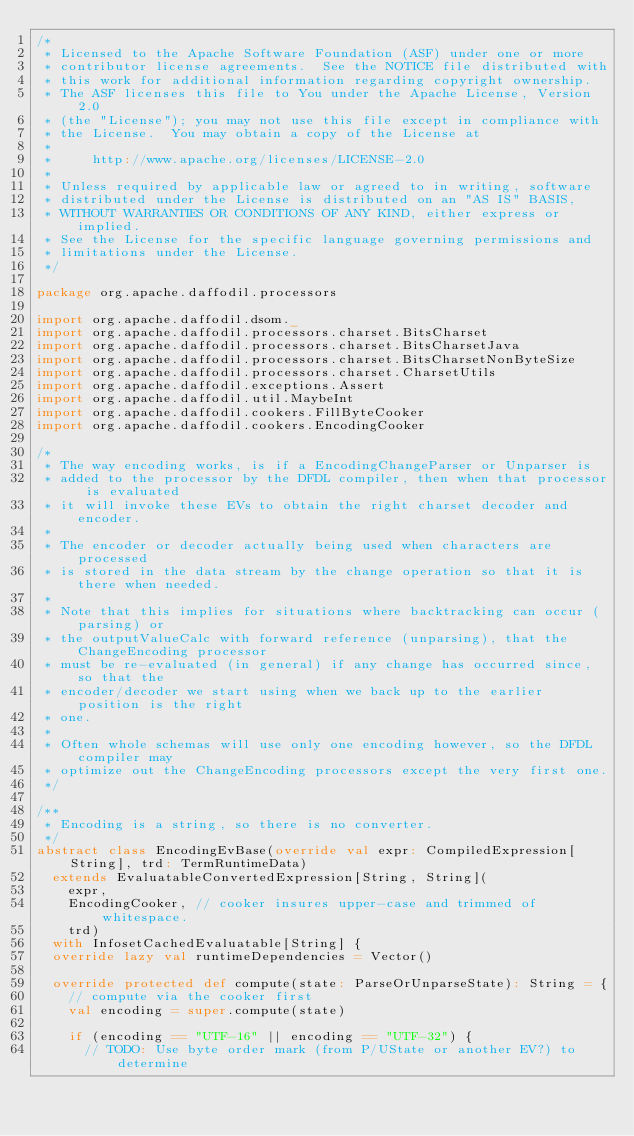Convert code to text. <code><loc_0><loc_0><loc_500><loc_500><_Scala_>/*
 * Licensed to the Apache Software Foundation (ASF) under one or more
 * contributor license agreements.  See the NOTICE file distributed with
 * this work for additional information regarding copyright ownership.
 * The ASF licenses this file to You under the Apache License, Version 2.0
 * (the "License"); you may not use this file except in compliance with
 * the License.  You may obtain a copy of the License at
 *
 *     http://www.apache.org/licenses/LICENSE-2.0
 *
 * Unless required by applicable law or agreed to in writing, software
 * distributed under the License is distributed on an "AS IS" BASIS,
 * WITHOUT WARRANTIES OR CONDITIONS OF ANY KIND, either express or implied.
 * See the License for the specific language governing permissions and
 * limitations under the License.
 */

package org.apache.daffodil.processors

import org.apache.daffodil.dsom._
import org.apache.daffodil.processors.charset.BitsCharset
import org.apache.daffodil.processors.charset.BitsCharsetJava
import org.apache.daffodil.processors.charset.BitsCharsetNonByteSize
import org.apache.daffodil.processors.charset.CharsetUtils
import org.apache.daffodil.exceptions.Assert
import org.apache.daffodil.util.MaybeInt
import org.apache.daffodil.cookers.FillByteCooker
import org.apache.daffodil.cookers.EncodingCooker

/*
 * The way encoding works, is if a EncodingChangeParser or Unparser is
 * added to the processor by the DFDL compiler, then when that processor is evaluated
 * it will invoke these EVs to obtain the right charset decoder and encoder.
 *
 * The encoder or decoder actually being used when characters are processed
 * is stored in the data stream by the change operation so that it is there when needed.
 *
 * Note that this implies for situations where backtracking can occur (parsing) or
 * the outputValueCalc with forward reference (unparsing), that the ChangeEncoding processor
 * must be re-evaluated (in general) if any change has occurred since, so that the
 * encoder/decoder we start using when we back up to the earlier position is the right
 * one.
 *
 * Often whole schemas will use only one encoding however, so the DFDL compiler may
 * optimize out the ChangeEncoding processors except the very first one.
 */

/**
 * Encoding is a string, so there is no converter.
 */
abstract class EncodingEvBase(override val expr: CompiledExpression[String], trd: TermRuntimeData)
  extends EvaluatableConvertedExpression[String, String](
    expr,
    EncodingCooker, // cooker insures upper-case and trimmed of whitespace.
    trd)
  with InfosetCachedEvaluatable[String] {
  override lazy val runtimeDependencies = Vector()

  override protected def compute(state: ParseOrUnparseState): String = {
    // compute via the cooker first
    val encoding = super.compute(state)

    if (encoding == "UTF-16" || encoding == "UTF-32") {
      // TODO: Use byte order mark (from P/UState or another EV?) to determine</code> 